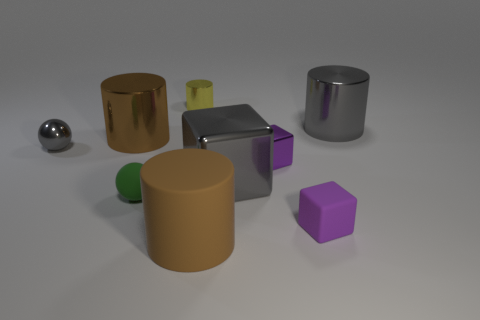Subtract all metallic cubes. How many cubes are left? 1 Add 1 tiny gray matte cylinders. How many objects exist? 10 Subtract all yellow cylinders. How many cylinders are left? 3 Subtract all balls. How many objects are left? 7 Subtract 1 spheres. How many spheres are left? 1 Subtract all small brown things. Subtract all gray cubes. How many objects are left? 8 Add 1 big brown shiny cylinders. How many big brown shiny cylinders are left? 2 Add 3 large brown metal objects. How many large brown metal objects exist? 4 Subtract 1 green balls. How many objects are left? 8 Subtract all red cylinders. Subtract all green cubes. How many cylinders are left? 4 